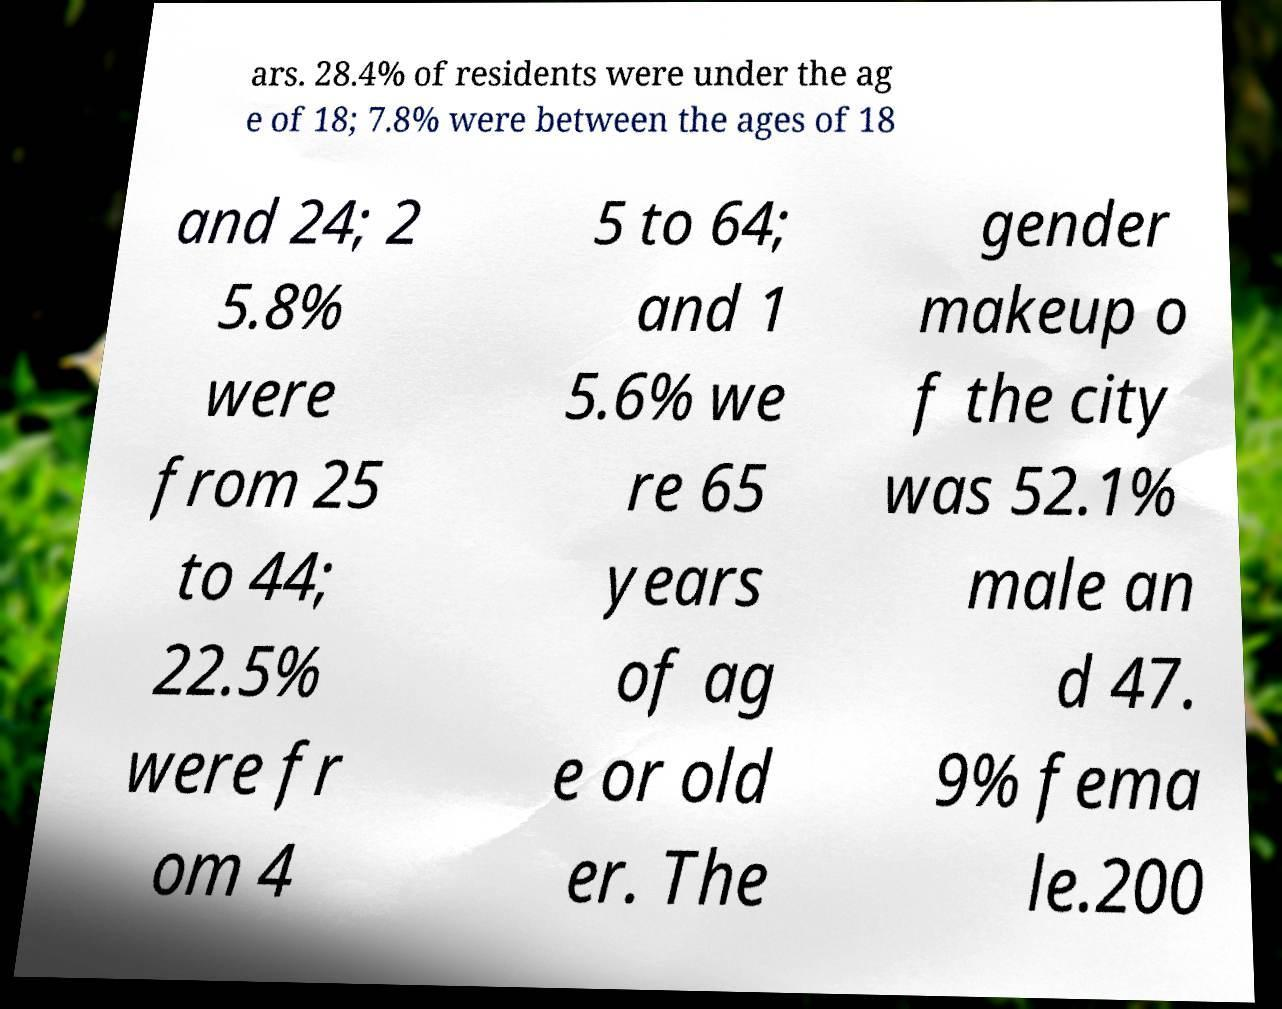For documentation purposes, I need the text within this image transcribed. Could you provide that? ars. 28.4% of residents were under the ag e of 18; 7.8% were between the ages of 18 and 24; 2 5.8% were from 25 to 44; 22.5% were fr om 4 5 to 64; and 1 5.6% we re 65 years of ag e or old er. The gender makeup o f the city was 52.1% male an d 47. 9% fema le.200 